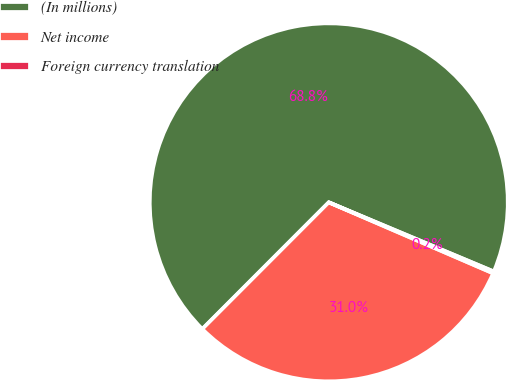<chart> <loc_0><loc_0><loc_500><loc_500><pie_chart><fcel>(In millions)<fcel>Net income<fcel>Foreign currency translation<nl><fcel>68.83%<fcel>31.0%<fcel>0.17%<nl></chart> 